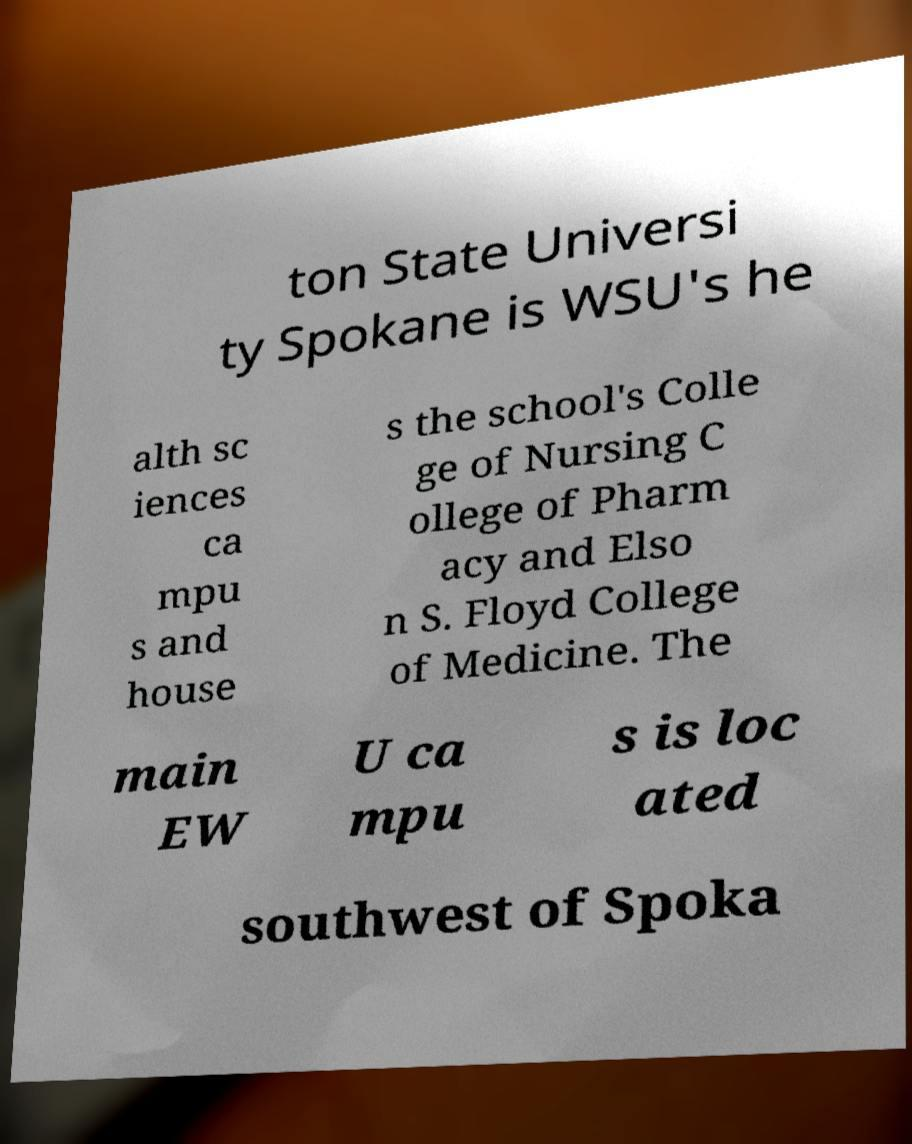What messages or text are displayed in this image? I need them in a readable, typed format. ton State Universi ty Spokane is WSU's he alth sc iences ca mpu s and house s the school's Colle ge of Nursing C ollege of Pharm acy and Elso n S. Floyd College of Medicine. The main EW U ca mpu s is loc ated southwest of Spoka 